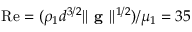<formula> <loc_0><loc_0><loc_500><loc_500>R e = ( \rho _ { 1 } d ^ { 3 / 2 } | | g | | ^ { 1 / 2 } ) / \mu _ { 1 } = 3 5</formula> 